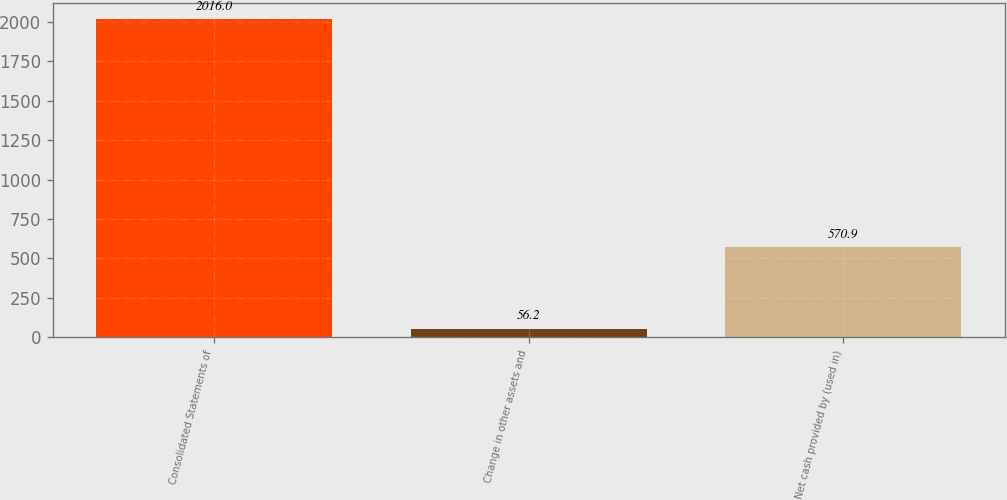Convert chart to OTSL. <chart><loc_0><loc_0><loc_500><loc_500><bar_chart><fcel>Consolidated Statements of<fcel>Change in other assets and<fcel>Net cash provided by (used in)<nl><fcel>2016<fcel>56.2<fcel>570.9<nl></chart> 